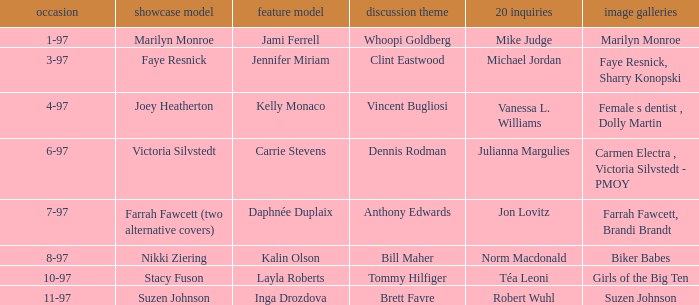What is the identity of the model featured on the cover of issue 3-97? Faye Resnick. 